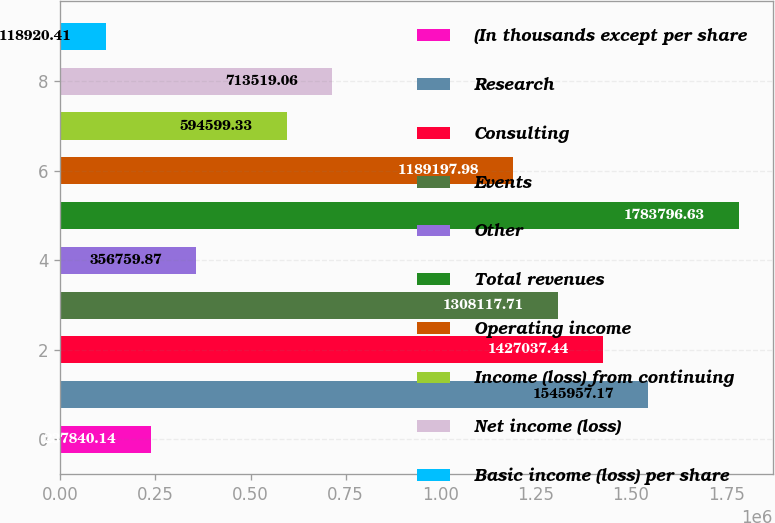Convert chart to OTSL. <chart><loc_0><loc_0><loc_500><loc_500><bar_chart><fcel>(In thousands except per share<fcel>Research<fcel>Consulting<fcel>Events<fcel>Other<fcel>Total revenues<fcel>Operating income<fcel>Income (loss) from continuing<fcel>Net income (loss)<fcel>Basic income (loss) per share<nl><fcel>237840<fcel>1.54596e+06<fcel>1.42704e+06<fcel>1.30812e+06<fcel>356760<fcel>1.7838e+06<fcel>1.1892e+06<fcel>594599<fcel>713519<fcel>118920<nl></chart> 